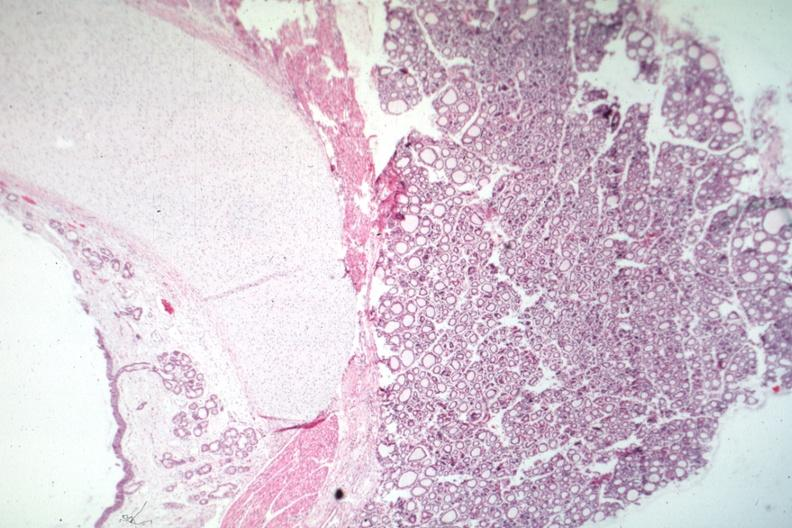what is present?
Answer the question using a single word or phrase. Thyroid 